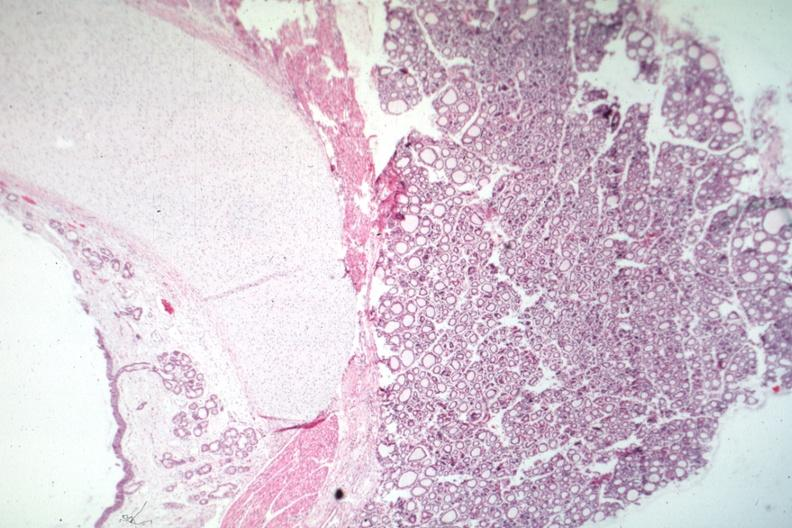what is present?
Answer the question using a single word or phrase. Thyroid 